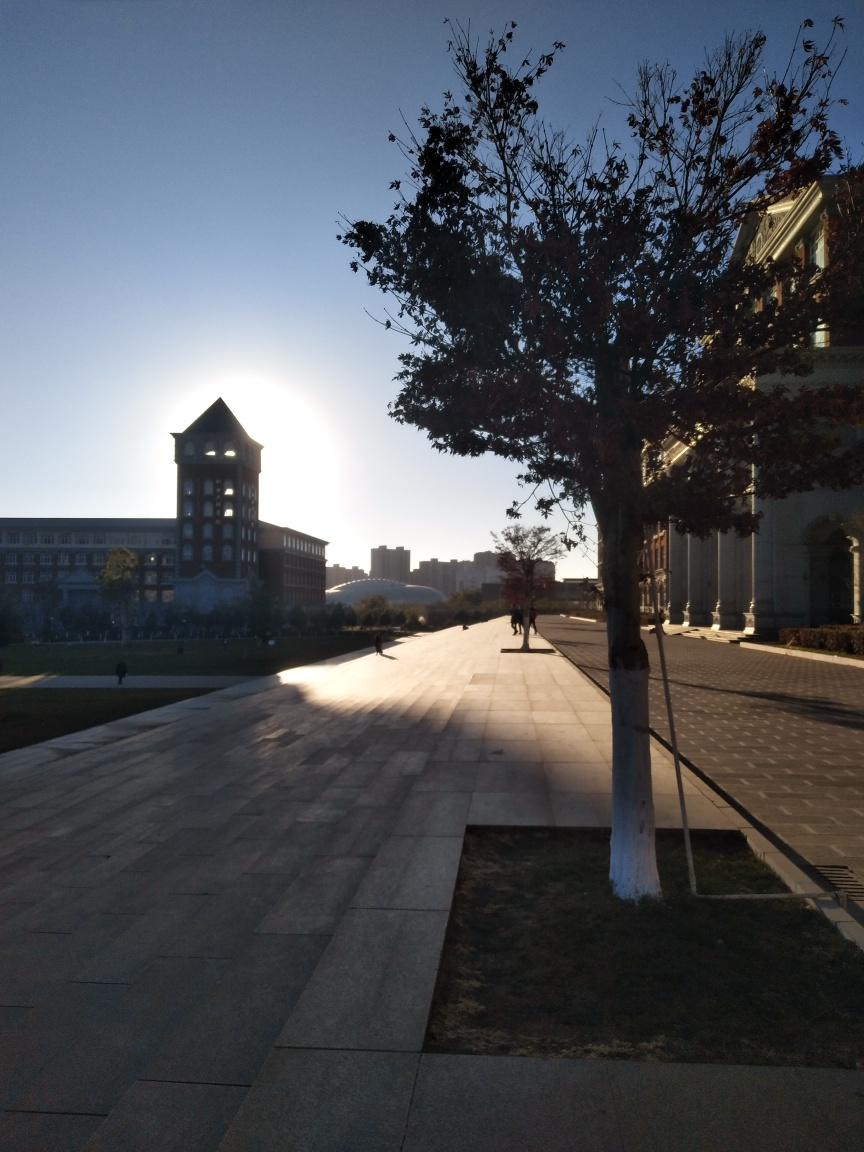What time of day does this image depict? The image captures a scene that appears to be at or near sunset, based on the position of the sun low on the horizon creating long shadows. 